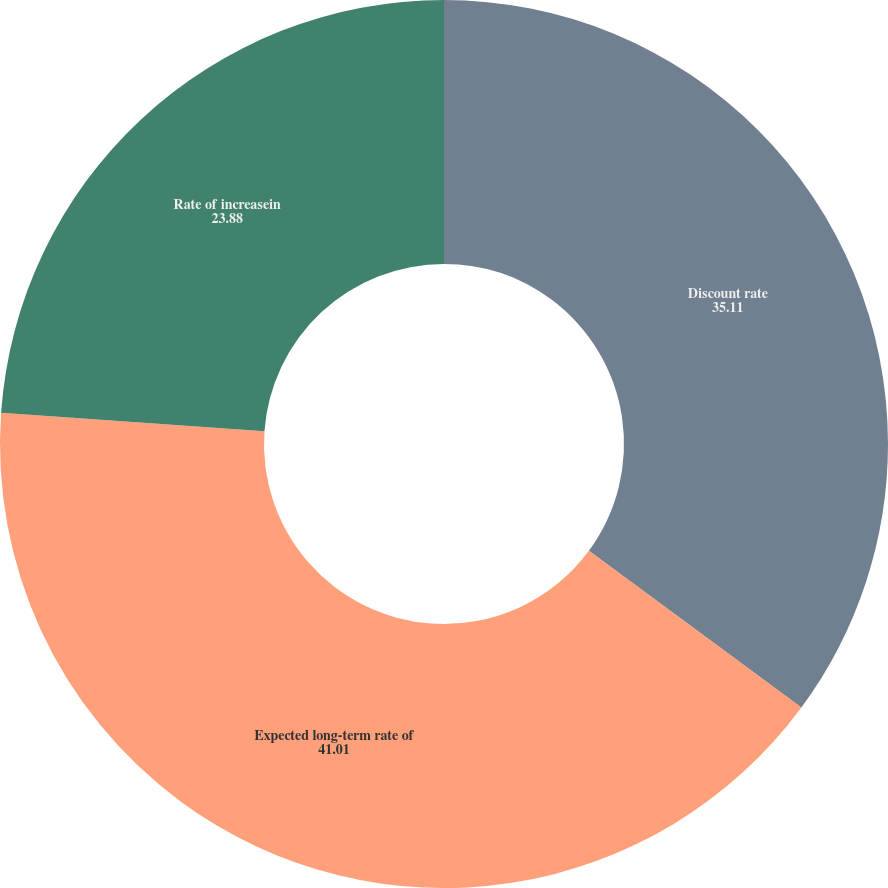<chart> <loc_0><loc_0><loc_500><loc_500><pie_chart><fcel>Discount rate<fcel>Expected long-term rate of<fcel>Rate of increasein<nl><fcel>35.11%<fcel>41.01%<fcel>23.88%<nl></chart> 